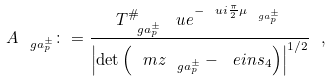Convert formula to latex. <formula><loc_0><loc_0><loc_500><loc_500>A _ { \ g a _ { p } ^ { \pm } } \colon = \frac { T _ { \ g a _ { p } ^ { \pm } } ^ { \# } \, \ u e ^ { - \ u i \frac { \pi } { 2 } \mu _ { \ g a _ { p } ^ { \pm } } } } { \left | \det \left ( \ m z _ { \ g a _ { p } ^ { \pm } } - \ e i n s _ { 4 } \right ) \right | ^ { 1 / 2 } } \ ,</formula> 